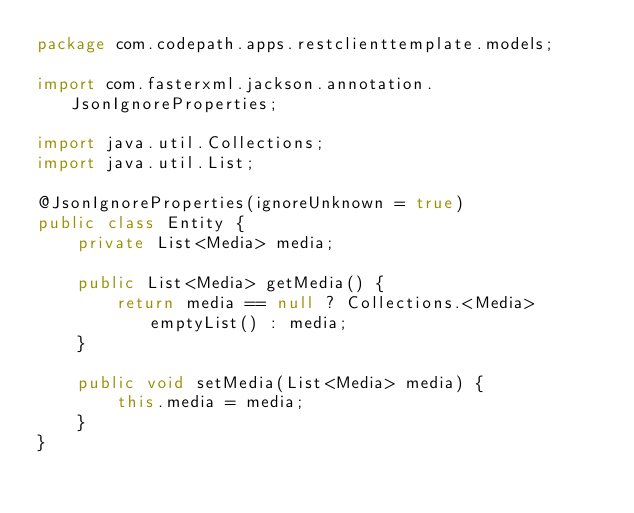<code> <loc_0><loc_0><loc_500><loc_500><_Java_>package com.codepath.apps.restclienttemplate.models;

import com.fasterxml.jackson.annotation.JsonIgnoreProperties;

import java.util.Collections;
import java.util.List;

@JsonIgnoreProperties(ignoreUnknown = true)
public class Entity {
    private List<Media> media;

    public List<Media> getMedia() {
        return media == null ? Collections.<Media>emptyList() : media;
    }

    public void setMedia(List<Media> media) {
        this.media = media;
    }
}
</code> 